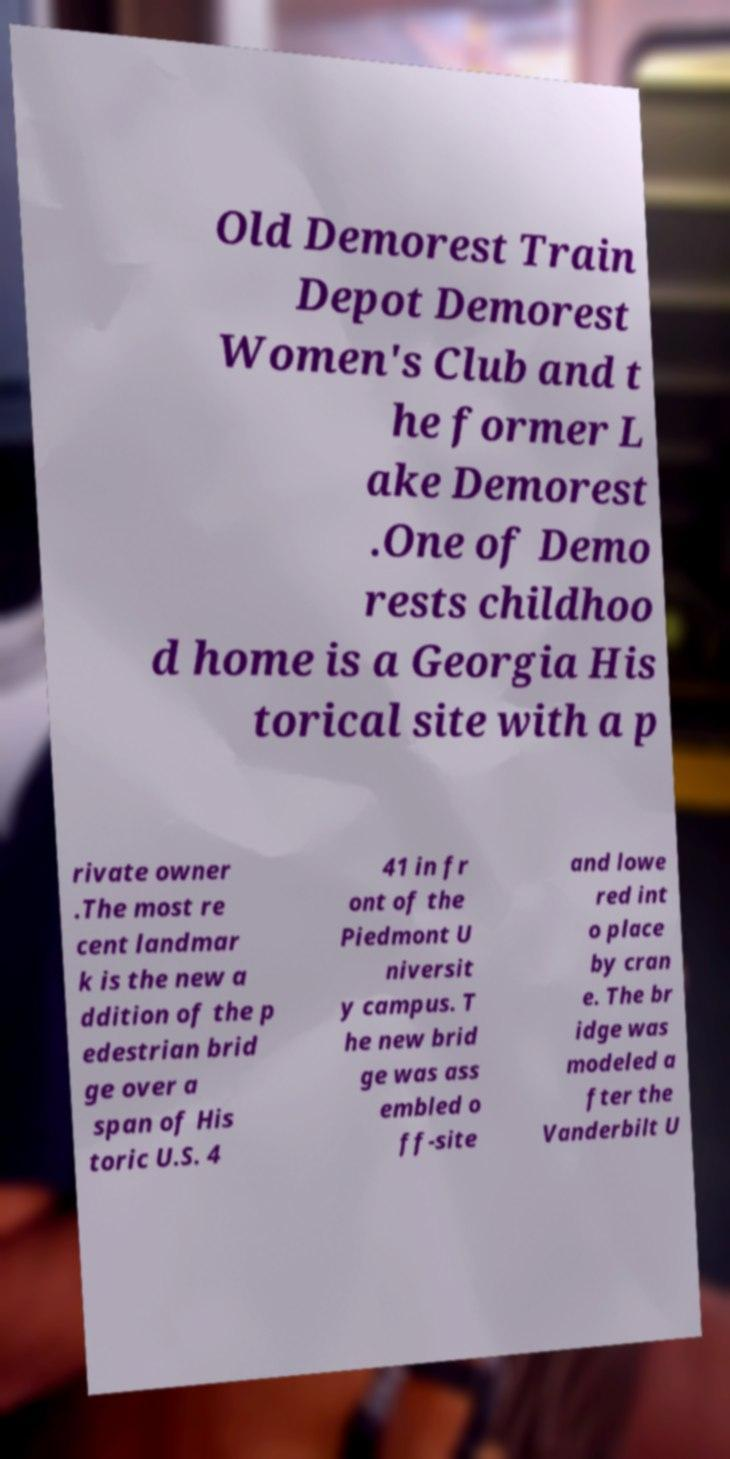What messages or text are displayed in this image? I need them in a readable, typed format. Old Demorest Train Depot Demorest Women's Club and t he former L ake Demorest .One of Demo rests childhoo d home is a Georgia His torical site with a p rivate owner .The most re cent landmar k is the new a ddition of the p edestrian brid ge over a span of His toric U.S. 4 41 in fr ont of the Piedmont U niversit y campus. T he new brid ge was ass embled o ff-site and lowe red int o place by cran e. The br idge was modeled a fter the Vanderbilt U 